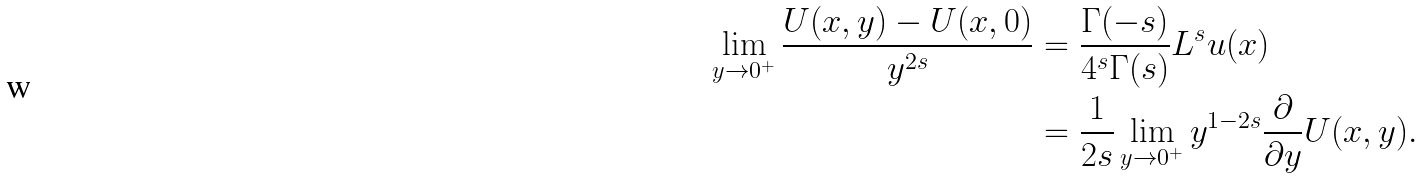Convert formula to latex. <formula><loc_0><loc_0><loc_500><loc_500>\lim _ { y \to 0 ^ { + } } \frac { U ( x , y ) - U ( x , 0 ) } { y ^ { 2 s } } & = \frac { \Gamma ( - s ) } { 4 ^ { s } \Gamma ( s ) } L ^ { s } u ( x ) \\ & = \frac { 1 } { 2 s } \lim _ { y \to 0 ^ { + } } y ^ { 1 - 2 s } \frac { \partial } { \partial y } U ( x , y ) .</formula> 